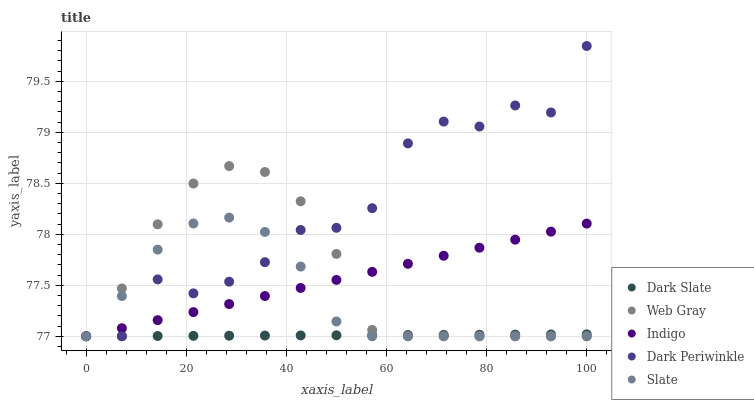Does Dark Slate have the minimum area under the curve?
Answer yes or no. Yes. Does Dark Periwinkle have the maximum area under the curve?
Answer yes or no. Yes. Does Slate have the minimum area under the curve?
Answer yes or no. No. Does Slate have the maximum area under the curve?
Answer yes or no. No. Is Indigo the smoothest?
Answer yes or no. Yes. Is Dark Periwinkle the roughest?
Answer yes or no. Yes. Is Slate the smoothest?
Answer yes or no. No. Is Slate the roughest?
Answer yes or no. No. Does Dark Slate have the lowest value?
Answer yes or no. Yes. Does Dark Periwinkle have the highest value?
Answer yes or no. Yes. Does Slate have the highest value?
Answer yes or no. No. Does Dark Slate intersect Dark Periwinkle?
Answer yes or no. Yes. Is Dark Slate less than Dark Periwinkle?
Answer yes or no. No. Is Dark Slate greater than Dark Periwinkle?
Answer yes or no. No. 